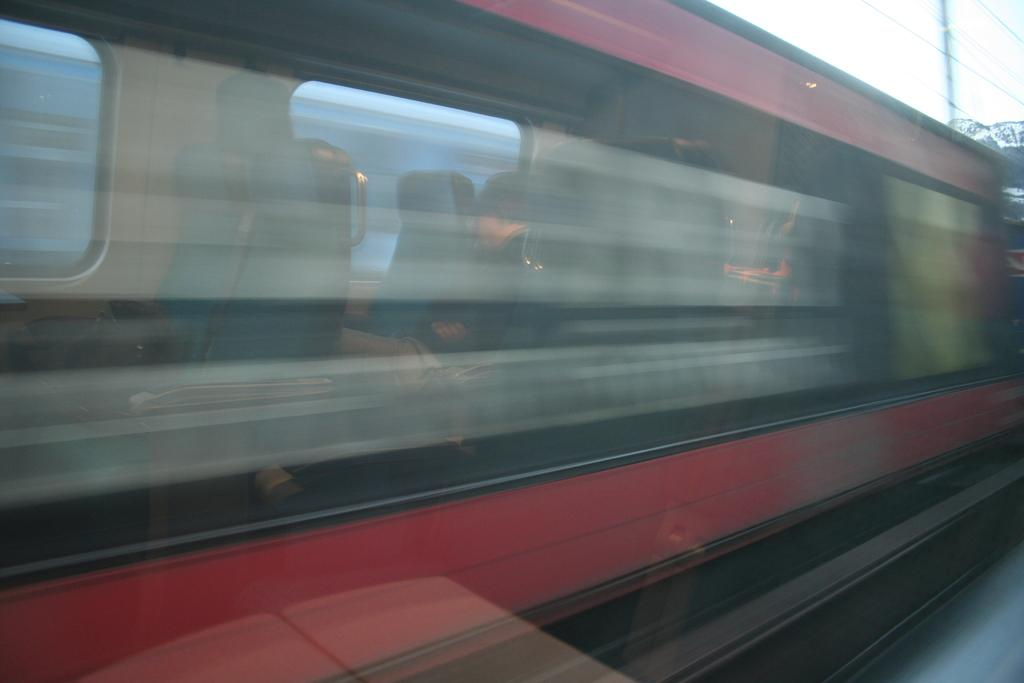What is located on the platform in the image? There is a train on the platform in the image. What can be seen in the background of the image? There is a pole and wires in the background of the image. What is visible above the pole and wires in the image? The sky is visible in the background of the image. What type of berry is being used to power the train in the image? There is no berry present in the image, and berries are not used to power trains. 